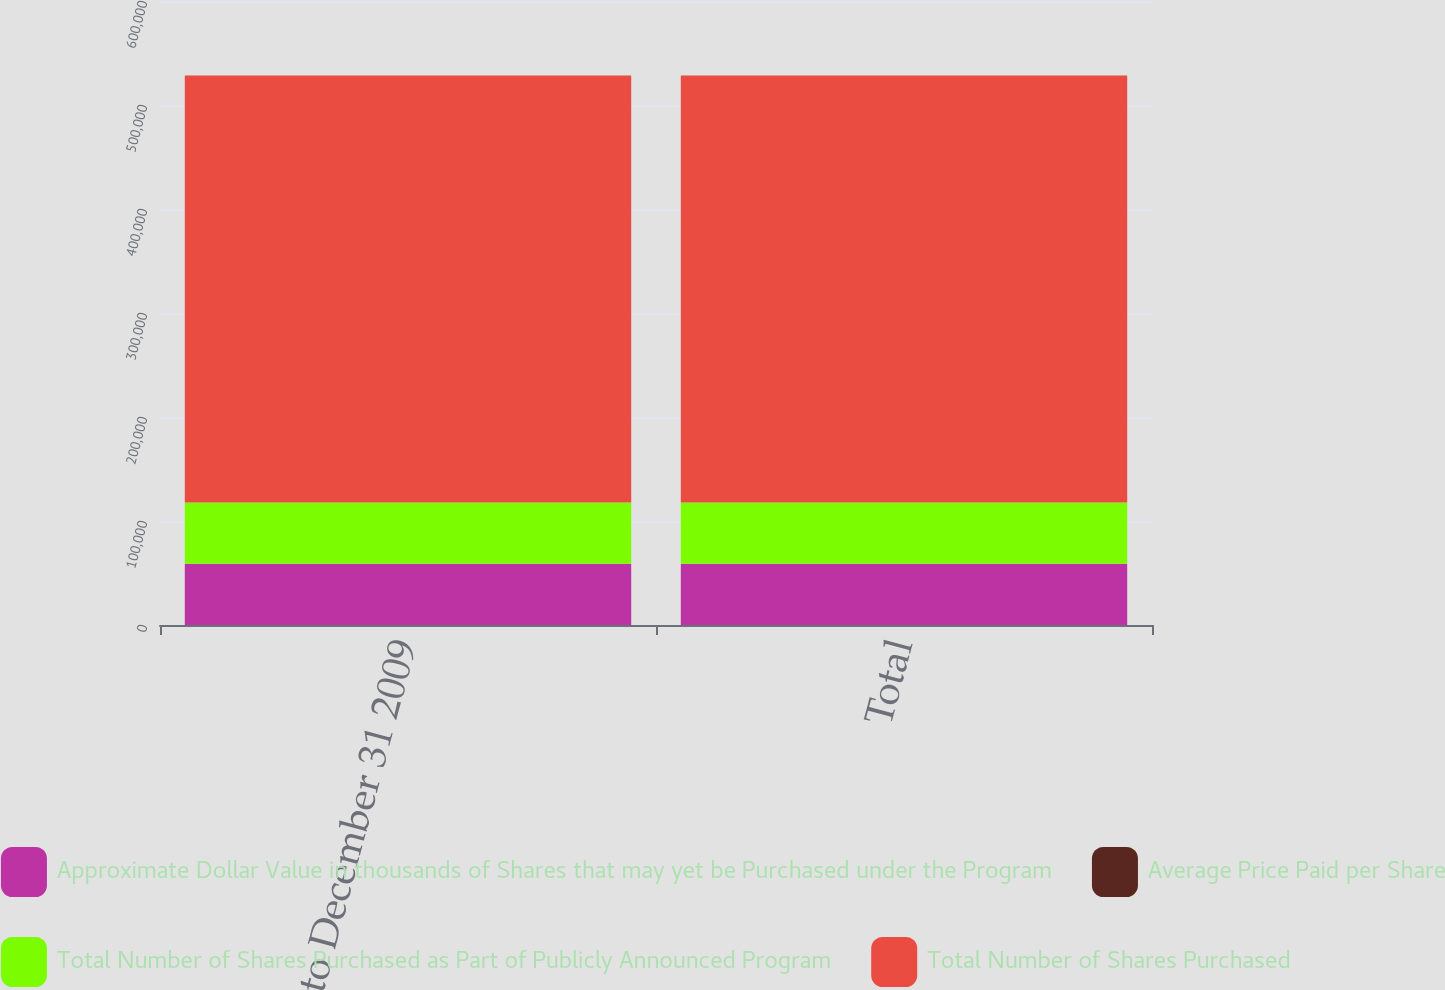Convert chart. <chart><loc_0><loc_0><loc_500><loc_500><stacked_bar_chart><ecel><fcel>December 1 to December 31 2009<fcel>Total<nl><fcel>Approximate Dollar Value in thousands of Shares that may yet be Purchased under the Program<fcel>58800<fcel>58800<nl><fcel>Average Price Paid per Share<fcel>101.82<fcel>101.82<nl><fcel>Total Number of Shares Purchased as Part of Publicly Announced Program<fcel>58800<fcel>58800<nl><fcel>Total Number of Shares Purchased<fcel>410603<fcel>410603<nl></chart> 